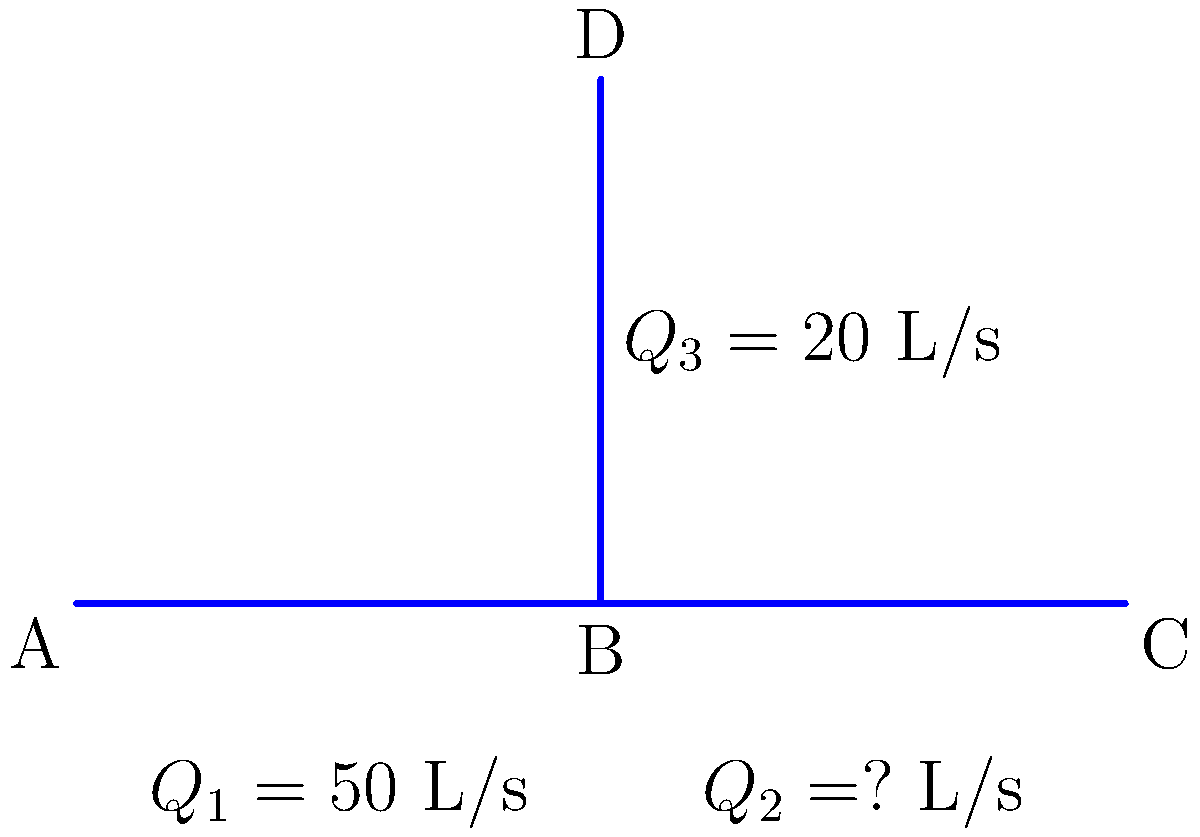In the pipe network shown above, water flows from point A to C, with a branch at point B leading to point D. Given that the flow rate from A to B ($Q_1$) is 50 L/s and the flow rate from B to D ($Q_3$) is 20 L/s, determine the flow rate from B to C ($Q_2$) in L/s. To solve this problem, we'll use the principle of conservation of mass, which states that the total inflow must equal the total outflow at any junction in a pipe network. Let's follow these steps:

1) Identify the junction: In this case, point B is our junction of interest.

2) Apply conservation of mass at point B:
   Inflow = Outflow
   $Q_1 = Q_2 + Q_3$

3) We know the values of $Q_1$ and $Q_3$:
   $Q_1 = 50$ L/s
   $Q_3 = 20$ L/s

4) Substitute these values into our equation:
   $50 = Q_2 + 20$

5) Solve for $Q_2$:
   $Q_2 = 50 - 20 = 30$ L/s

Therefore, the flow rate from B to C ($Q_2$) is 30 L/s.
Answer: 30 L/s 